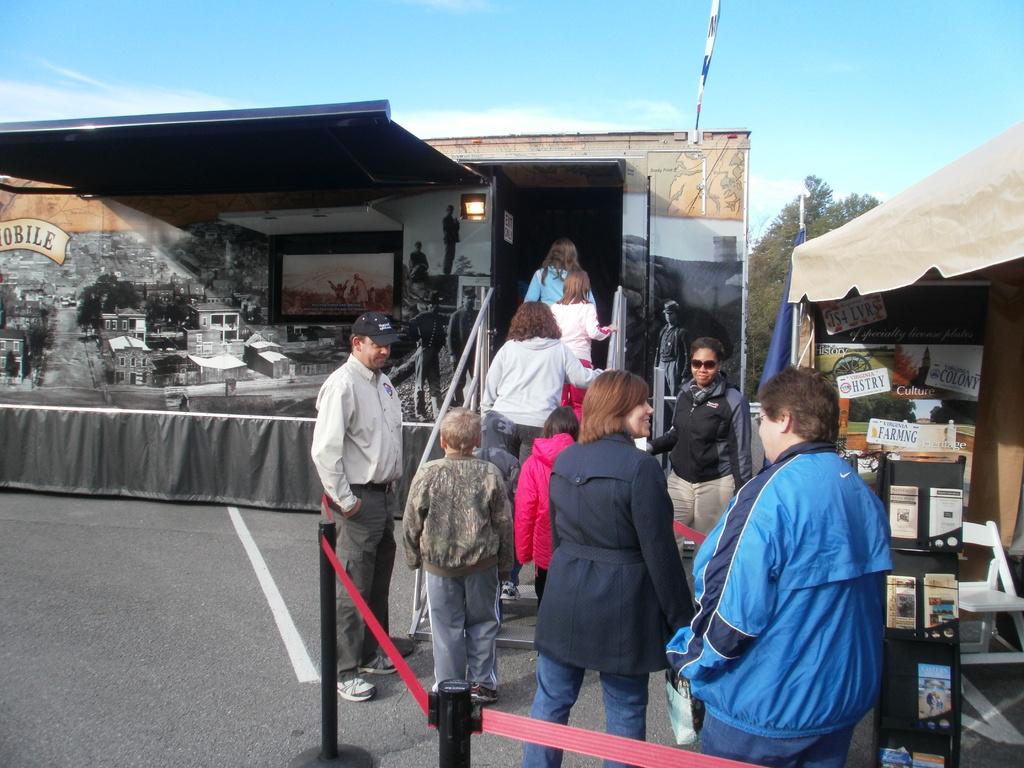What does it say on the banner on the far left?
Your response must be concise. Obile. 